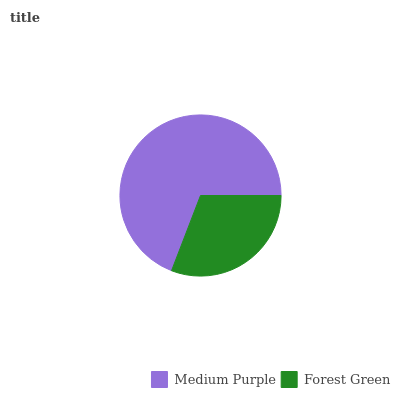Is Forest Green the minimum?
Answer yes or no. Yes. Is Medium Purple the maximum?
Answer yes or no. Yes. Is Forest Green the maximum?
Answer yes or no. No. Is Medium Purple greater than Forest Green?
Answer yes or no. Yes. Is Forest Green less than Medium Purple?
Answer yes or no. Yes. Is Forest Green greater than Medium Purple?
Answer yes or no. No. Is Medium Purple less than Forest Green?
Answer yes or no. No. Is Medium Purple the high median?
Answer yes or no. Yes. Is Forest Green the low median?
Answer yes or no. Yes. Is Forest Green the high median?
Answer yes or no. No. Is Medium Purple the low median?
Answer yes or no. No. 